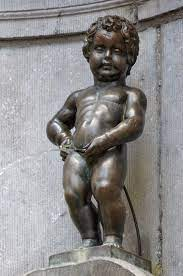Explain the visual content of the image in great detail. The image showcases the Manneken Pis, a famous sculpture in Brussels, Belgium. Cast in bronze, the sculpture portrays a naked little boy standing on a pedestal, urinating into a basin of a fountain. This characterful statue stands at just 61 cm tall, a detail that often surprises visitors given its fame. The surrounding wall is comprised of weathered stone bricks, offering a humble backdrop that contrasts with the statue's polished surface. Greenish patina hues and streaks of wear add to the statue's aged look, suggesting a rich history which includes numerous anecdotes and legends. Moreover, the Manneken Pis is no stranger to attire; it is dressed in costumes on various occasions, boasting a wardrobe of over 1,000 different outfits that reflect various international cultures, professions, and festivities, symbolizing the city's sense of humor and quirky embrace of tradition. 